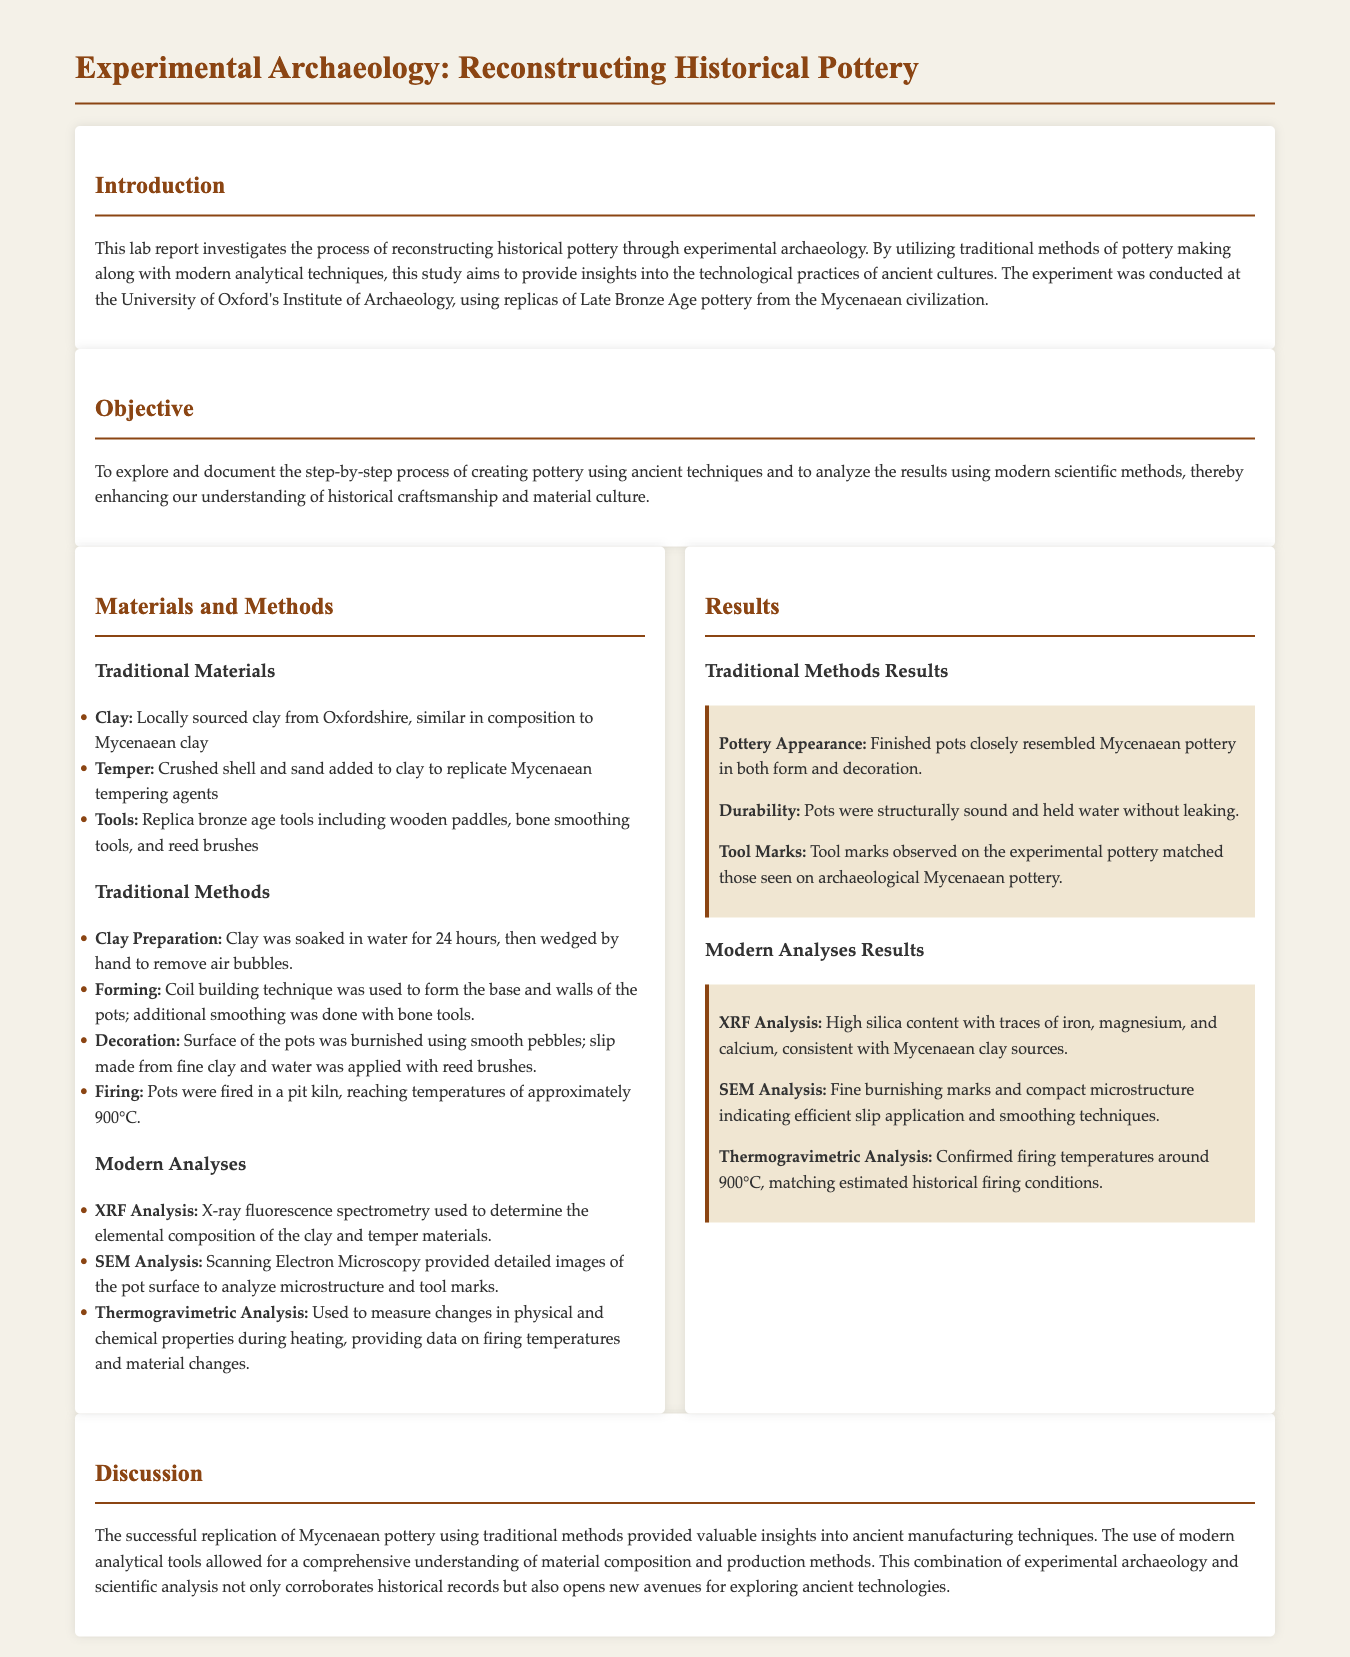What is the main focus of the lab report? The lab report focuses on reconstructing historical pottery through experimental archaeology.
Answer: reconstructing historical pottery Where was the experiment conducted? The experiment was conducted at the University of Oxford's Institute of Archaeology.
Answer: University of Oxford What type of analysis was used to determine the elemental composition? X-ray fluorescence spectrometry was used for this purpose.
Answer: XRF Analysis What method was used for forming the pottery? The coil building technique was used to form the pottery.
Answer: coil building Which ancient civilization's pottery was replicated? The pottery from the Mycenaean civilization was replicated.
Answer: Mycenaean What was the firing temperature reached in the pit kiln? The pots were fired at approximately 900°C.
Answer: 900°C What insight does the combination of experimental archaeology and scientific analysis provide? It provides a comprehensive understanding of material composition and production methods.
Answer: comprehensive understanding What materials were used to replicate the ancient tempering agents? Crushed shell and sand were used as tempering agents.
Answer: crushed shell and sand 